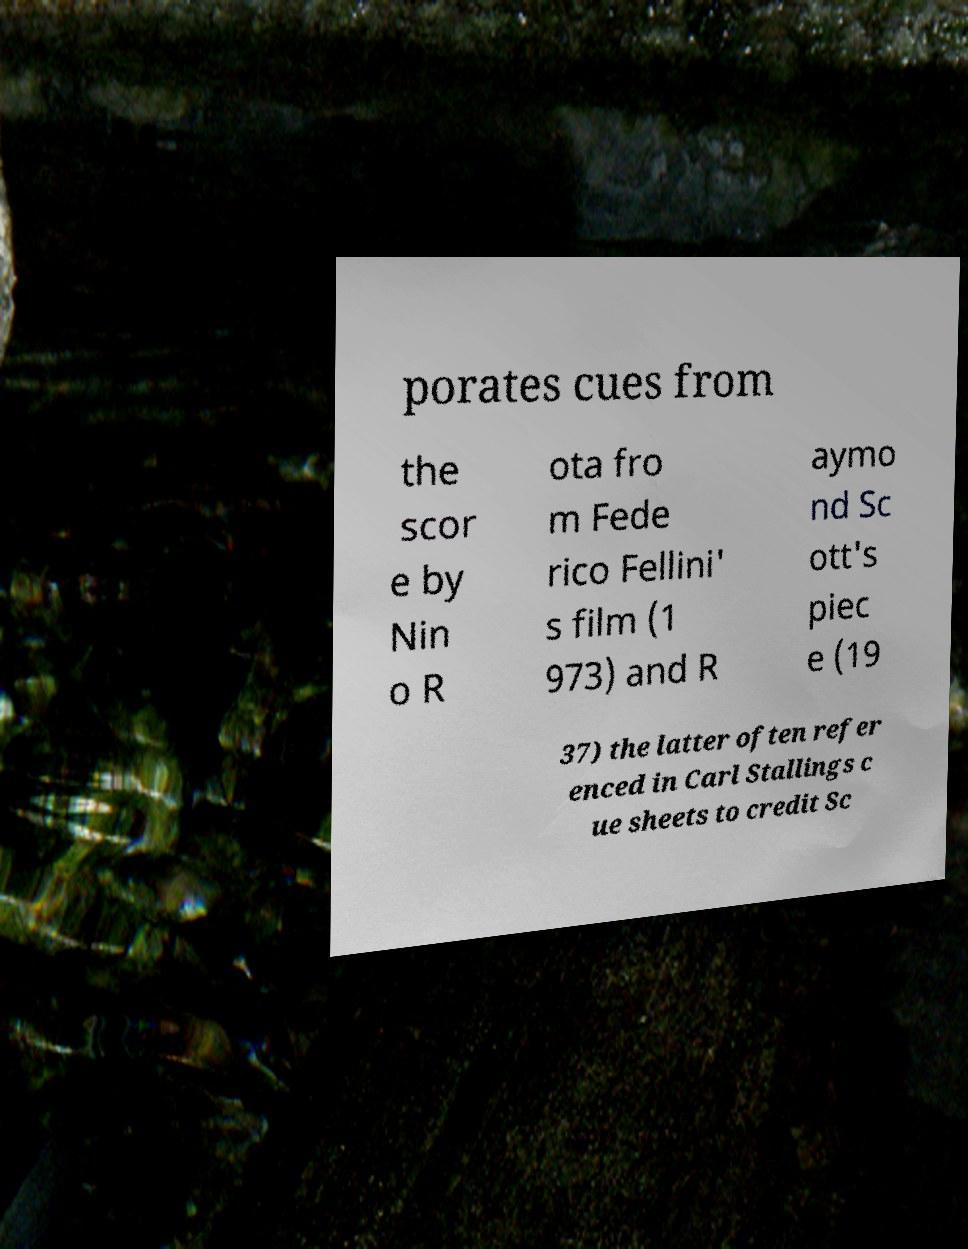What messages or text are displayed in this image? I need them in a readable, typed format. porates cues from the scor e by Nin o R ota fro m Fede rico Fellini' s film (1 973) and R aymo nd Sc ott's piec e (19 37) the latter often refer enced in Carl Stallings c ue sheets to credit Sc 